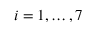Convert formula to latex. <formula><loc_0><loc_0><loc_500><loc_500>i = 1 , \dots , 7</formula> 